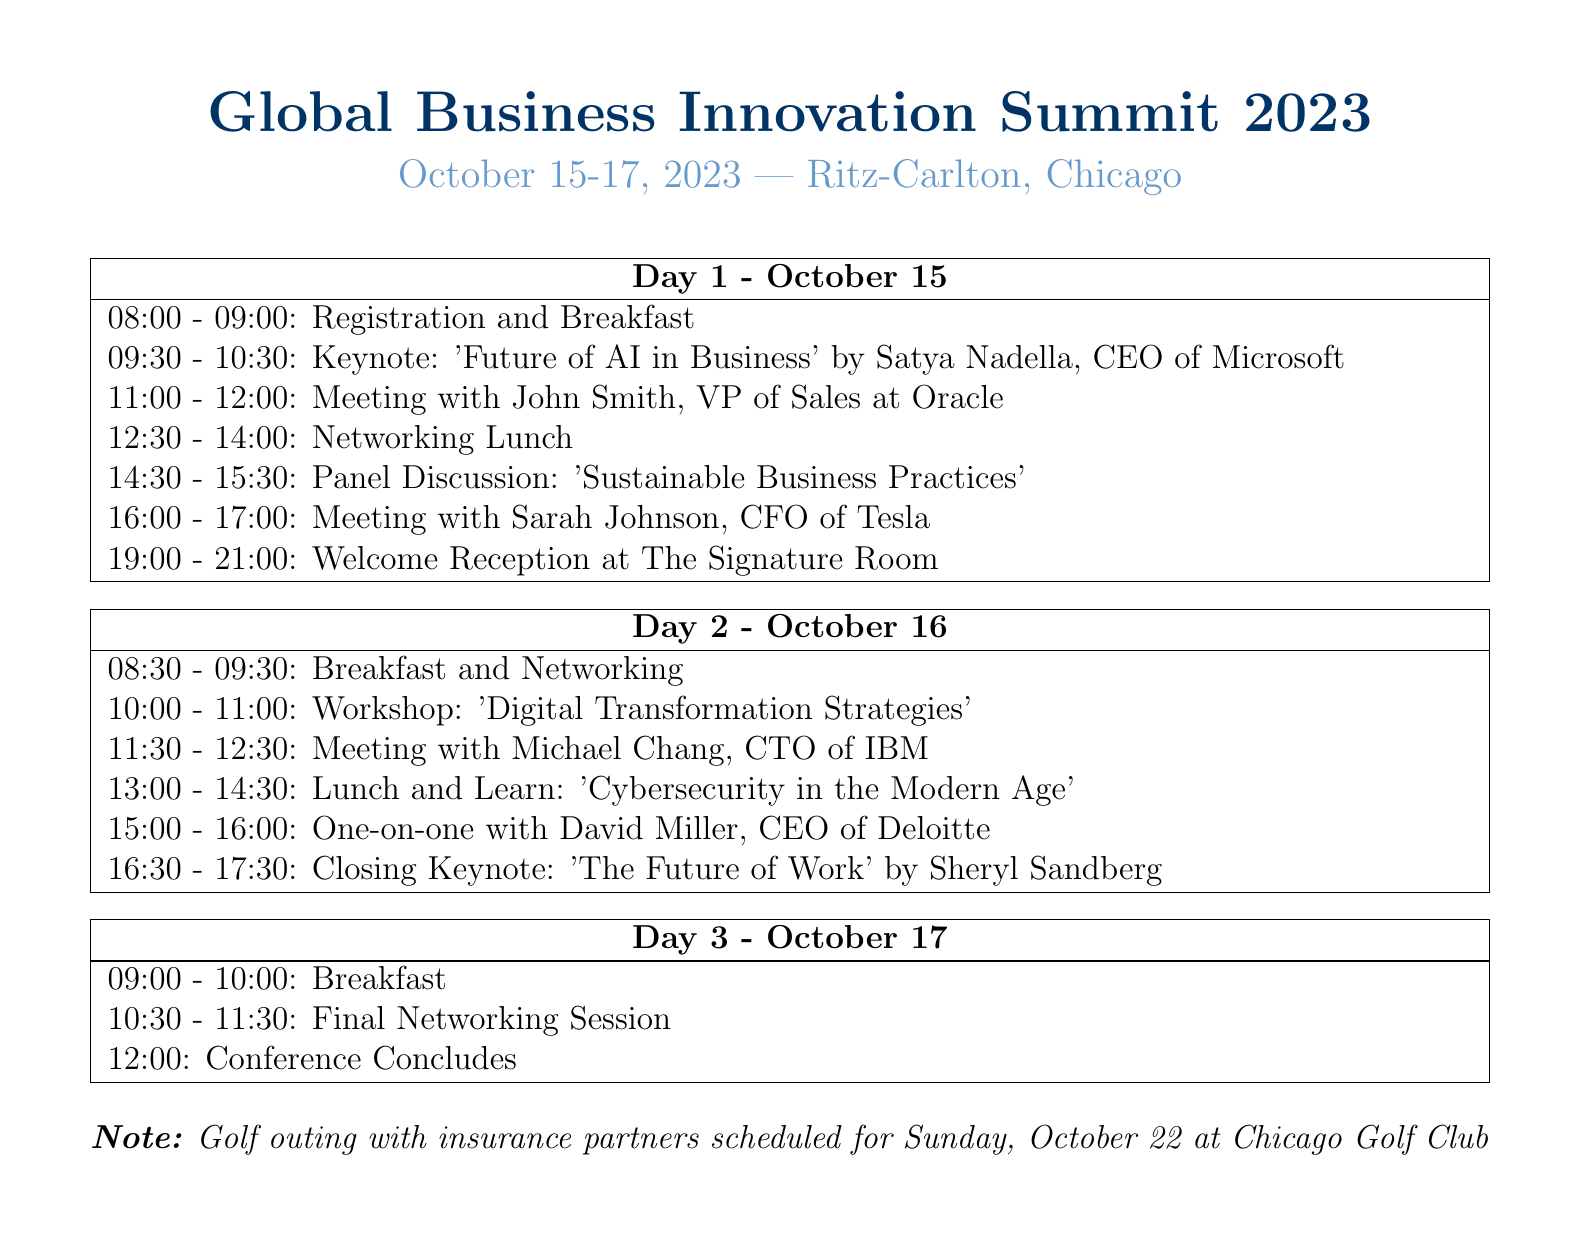What are the dates of the conference? The dates of the conference are clearly stated at the beginning of the document.
Answer: October 15-17, 2023 Who is the keynote speaker on Day 1? The document mentions the keynote speaker for Day 1 in the scheduled events.
Answer: Satya Nadella What time does the breakfast start on Day 2? Breakfast timing for Day 2 is provided in the itinerary listed under Day 2 events.
Answer: 08:30 Which company will be meeting the CEO of Deloitte? The document specifies the meeting on Day 2, indicating who will meet the CEO of Deloitte.
Answer: One-on-one with David Miller What is the title of the closing keynote speaker? The title of the closing keynote speaker is noted among the Day 2 events.
Answer: 'The Future of Work' How many networking events are scheduled during the conference? The document highlights all networking events scheduled within the itinerary.
Answer: 2 What is the location of the conference? The location of the conference is mentioned at the top of the document.
Answer: Ritz-Carlton, Chicago What is planned after the final networking session? The itinerary specifies the actions following the final networking session on Day 3.
Answer: Conference Concludes When is the golf outing scheduled? The golf outing schedule is indicated in the notes at the end of the document.
Answer: Sunday, October 22 